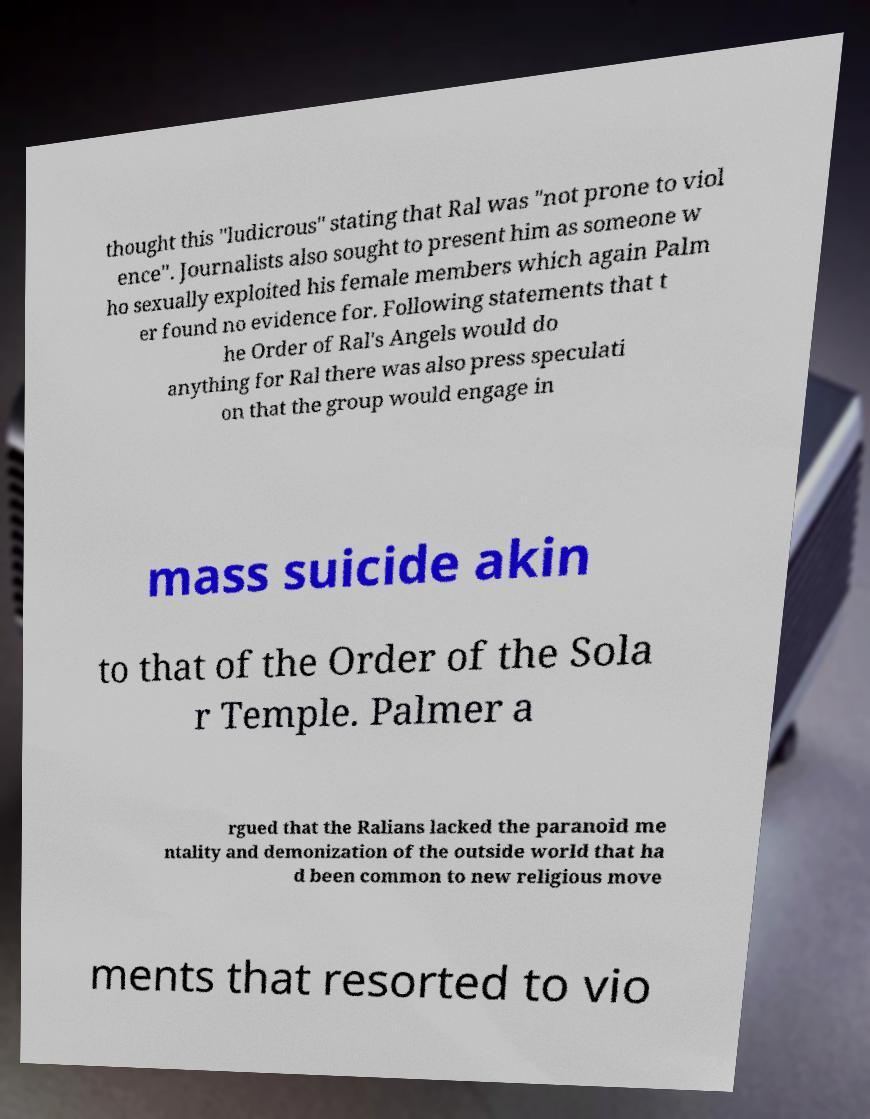I need the written content from this picture converted into text. Can you do that? thought this "ludicrous" stating that Ral was "not prone to viol ence". Journalists also sought to present him as someone w ho sexually exploited his female members which again Palm er found no evidence for. Following statements that t he Order of Ral's Angels would do anything for Ral there was also press speculati on that the group would engage in mass suicide akin to that of the Order of the Sola r Temple. Palmer a rgued that the Ralians lacked the paranoid me ntality and demonization of the outside world that ha d been common to new religious move ments that resorted to vio 